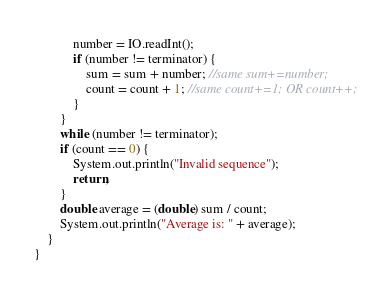Convert code to text. <code><loc_0><loc_0><loc_500><loc_500><_Java_>			number = IO.readInt();
			if (number != terminator) {
				sum = sum + number; //same sum+=number;
				count = count + 1; //same count+=1; OR count++;
			}
		}
		while (number != terminator);
		if (count == 0) {
			System.out.println("Invalid sequence");
			return;
		}
		double average = (double) sum / count;
		System.out.println("Average is: " + average);
	}
}
</code> 